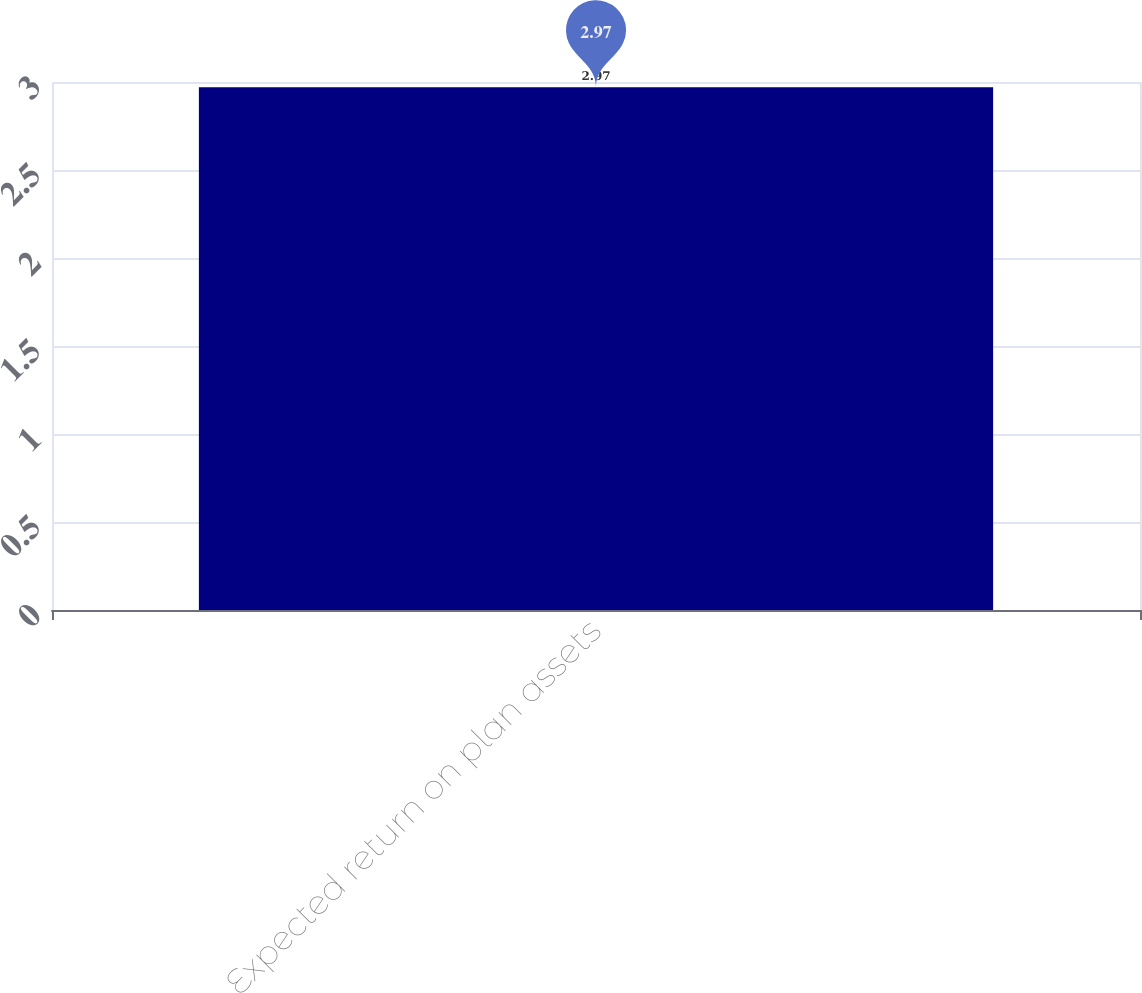<chart> <loc_0><loc_0><loc_500><loc_500><bar_chart><fcel>Expected return on plan assets<nl><fcel>2.97<nl></chart> 